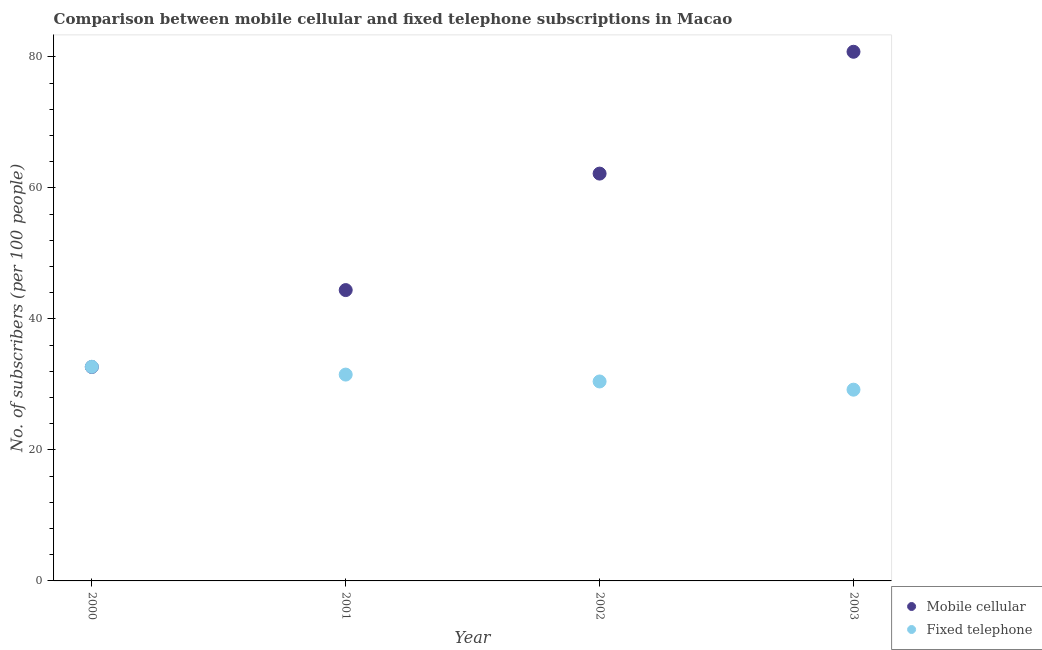How many different coloured dotlines are there?
Your answer should be compact. 2. What is the number of mobile cellular subscribers in 2000?
Provide a succinct answer. 32.66. Across all years, what is the maximum number of fixed telephone subscribers?
Your answer should be very brief. 32.68. Across all years, what is the minimum number of mobile cellular subscribers?
Keep it short and to the point. 32.66. In which year was the number of fixed telephone subscribers maximum?
Give a very brief answer. 2000. In which year was the number of fixed telephone subscribers minimum?
Make the answer very short. 2003. What is the total number of mobile cellular subscribers in the graph?
Offer a terse response. 219.99. What is the difference between the number of mobile cellular subscribers in 2000 and that in 2002?
Provide a succinct answer. -29.51. What is the difference between the number of mobile cellular subscribers in 2003 and the number of fixed telephone subscribers in 2000?
Offer a terse response. 48.08. What is the average number of mobile cellular subscribers per year?
Offer a terse response. 55. In the year 2000, what is the difference between the number of mobile cellular subscribers and number of fixed telephone subscribers?
Provide a succinct answer. -0.03. What is the ratio of the number of mobile cellular subscribers in 2002 to that in 2003?
Give a very brief answer. 0.77. Is the difference between the number of fixed telephone subscribers in 2000 and 2001 greater than the difference between the number of mobile cellular subscribers in 2000 and 2001?
Provide a short and direct response. Yes. What is the difference between the highest and the second highest number of mobile cellular subscribers?
Give a very brief answer. 18.6. What is the difference between the highest and the lowest number of mobile cellular subscribers?
Keep it short and to the point. 48.11. Does the number of fixed telephone subscribers monotonically increase over the years?
Keep it short and to the point. No. Are the values on the major ticks of Y-axis written in scientific E-notation?
Provide a short and direct response. No. Does the graph contain any zero values?
Ensure brevity in your answer.  No. Does the graph contain grids?
Your answer should be compact. No. Where does the legend appear in the graph?
Your answer should be compact. Bottom right. How many legend labels are there?
Offer a very short reply. 2. How are the legend labels stacked?
Offer a terse response. Vertical. What is the title of the graph?
Offer a very short reply. Comparison between mobile cellular and fixed telephone subscriptions in Macao. What is the label or title of the Y-axis?
Make the answer very short. No. of subscribers (per 100 people). What is the No. of subscribers (per 100 people) in Mobile cellular in 2000?
Your response must be concise. 32.66. What is the No. of subscribers (per 100 people) in Fixed telephone in 2000?
Give a very brief answer. 32.68. What is the No. of subscribers (per 100 people) of Mobile cellular in 2001?
Your answer should be very brief. 44.39. What is the No. of subscribers (per 100 people) of Fixed telephone in 2001?
Offer a very short reply. 31.49. What is the No. of subscribers (per 100 people) in Mobile cellular in 2002?
Offer a terse response. 62.17. What is the No. of subscribers (per 100 people) of Fixed telephone in 2002?
Provide a succinct answer. 30.44. What is the No. of subscribers (per 100 people) in Mobile cellular in 2003?
Your response must be concise. 80.77. What is the No. of subscribers (per 100 people) of Fixed telephone in 2003?
Ensure brevity in your answer.  29.19. Across all years, what is the maximum No. of subscribers (per 100 people) of Mobile cellular?
Offer a terse response. 80.77. Across all years, what is the maximum No. of subscribers (per 100 people) of Fixed telephone?
Make the answer very short. 32.68. Across all years, what is the minimum No. of subscribers (per 100 people) in Mobile cellular?
Provide a short and direct response. 32.66. Across all years, what is the minimum No. of subscribers (per 100 people) of Fixed telephone?
Provide a short and direct response. 29.19. What is the total No. of subscribers (per 100 people) of Mobile cellular in the graph?
Keep it short and to the point. 219.99. What is the total No. of subscribers (per 100 people) in Fixed telephone in the graph?
Offer a terse response. 123.81. What is the difference between the No. of subscribers (per 100 people) of Mobile cellular in 2000 and that in 2001?
Offer a terse response. -11.73. What is the difference between the No. of subscribers (per 100 people) of Fixed telephone in 2000 and that in 2001?
Keep it short and to the point. 1.19. What is the difference between the No. of subscribers (per 100 people) of Mobile cellular in 2000 and that in 2002?
Your response must be concise. -29.51. What is the difference between the No. of subscribers (per 100 people) of Fixed telephone in 2000 and that in 2002?
Ensure brevity in your answer.  2.24. What is the difference between the No. of subscribers (per 100 people) in Mobile cellular in 2000 and that in 2003?
Your answer should be compact. -48.11. What is the difference between the No. of subscribers (per 100 people) in Fixed telephone in 2000 and that in 2003?
Your answer should be compact. 3.49. What is the difference between the No. of subscribers (per 100 people) in Mobile cellular in 2001 and that in 2002?
Offer a very short reply. -17.78. What is the difference between the No. of subscribers (per 100 people) in Fixed telephone in 2001 and that in 2002?
Make the answer very short. 1.05. What is the difference between the No. of subscribers (per 100 people) of Mobile cellular in 2001 and that in 2003?
Make the answer very short. -36.38. What is the difference between the No. of subscribers (per 100 people) in Fixed telephone in 2001 and that in 2003?
Your answer should be very brief. 2.3. What is the difference between the No. of subscribers (per 100 people) in Mobile cellular in 2002 and that in 2003?
Offer a terse response. -18.6. What is the difference between the No. of subscribers (per 100 people) in Fixed telephone in 2002 and that in 2003?
Your response must be concise. 1.25. What is the difference between the No. of subscribers (per 100 people) of Mobile cellular in 2000 and the No. of subscribers (per 100 people) of Fixed telephone in 2001?
Provide a succinct answer. 1.16. What is the difference between the No. of subscribers (per 100 people) of Mobile cellular in 2000 and the No. of subscribers (per 100 people) of Fixed telephone in 2002?
Ensure brevity in your answer.  2.21. What is the difference between the No. of subscribers (per 100 people) of Mobile cellular in 2000 and the No. of subscribers (per 100 people) of Fixed telephone in 2003?
Ensure brevity in your answer.  3.47. What is the difference between the No. of subscribers (per 100 people) in Mobile cellular in 2001 and the No. of subscribers (per 100 people) in Fixed telephone in 2002?
Offer a very short reply. 13.95. What is the difference between the No. of subscribers (per 100 people) of Mobile cellular in 2001 and the No. of subscribers (per 100 people) of Fixed telephone in 2003?
Your answer should be compact. 15.2. What is the difference between the No. of subscribers (per 100 people) of Mobile cellular in 2002 and the No. of subscribers (per 100 people) of Fixed telephone in 2003?
Offer a terse response. 32.98. What is the average No. of subscribers (per 100 people) of Mobile cellular per year?
Offer a terse response. 55. What is the average No. of subscribers (per 100 people) in Fixed telephone per year?
Offer a very short reply. 30.95. In the year 2000, what is the difference between the No. of subscribers (per 100 people) of Mobile cellular and No. of subscribers (per 100 people) of Fixed telephone?
Offer a terse response. -0.03. In the year 2001, what is the difference between the No. of subscribers (per 100 people) of Mobile cellular and No. of subscribers (per 100 people) of Fixed telephone?
Ensure brevity in your answer.  12.9. In the year 2002, what is the difference between the No. of subscribers (per 100 people) in Mobile cellular and No. of subscribers (per 100 people) in Fixed telephone?
Your answer should be compact. 31.73. In the year 2003, what is the difference between the No. of subscribers (per 100 people) in Mobile cellular and No. of subscribers (per 100 people) in Fixed telephone?
Offer a very short reply. 51.58. What is the ratio of the No. of subscribers (per 100 people) of Mobile cellular in 2000 to that in 2001?
Offer a very short reply. 0.74. What is the ratio of the No. of subscribers (per 100 people) in Fixed telephone in 2000 to that in 2001?
Give a very brief answer. 1.04. What is the ratio of the No. of subscribers (per 100 people) of Mobile cellular in 2000 to that in 2002?
Keep it short and to the point. 0.53. What is the ratio of the No. of subscribers (per 100 people) of Fixed telephone in 2000 to that in 2002?
Provide a short and direct response. 1.07. What is the ratio of the No. of subscribers (per 100 people) in Mobile cellular in 2000 to that in 2003?
Give a very brief answer. 0.4. What is the ratio of the No. of subscribers (per 100 people) of Fixed telephone in 2000 to that in 2003?
Ensure brevity in your answer.  1.12. What is the ratio of the No. of subscribers (per 100 people) in Mobile cellular in 2001 to that in 2002?
Make the answer very short. 0.71. What is the ratio of the No. of subscribers (per 100 people) in Fixed telephone in 2001 to that in 2002?
Offer a terse response. 1.03. What is the ratio of the No. of subscribers (per 100 people) in Mobile cellular in 2001 to that in 2003?
Your answer should be very brief. 0.55. What is the ratio of the No. of subscribers (per 100 people) in Fixed telephone in 2001 to that in 2003?
Ensure brevity in your answer.  1.08. What is the ratio of the No. of subscribers (per 100 people) in Mobile cellular in 2002 to that in 2003?
Offer a terse response. 0.77. What is the ratio of the No. of subscribers (per 100 people) in Fixed telephone in 2002 to that in 2003?
Provide a succinct answer. 1.04. What is the difference between the highest and the second highest No. of subscribers (per 100 people) of Mobile cellular?
Provide a short and direct response. 18.6. What is the difference between the highest and the second highest No. of subscribers (per 100 people) of Fixed telephone?
Provide a short and direct response. 1.19. What is the difference between the highest and the lowest No. of subscribers (per 100 people) in Mobile cellular?
Ensure brevity in your answer.  48.11. What is the difference between the highest and the lowest No. of subscribers (per 100 people) in Fixed telephone?
Your answer should be compact. 3.49. 